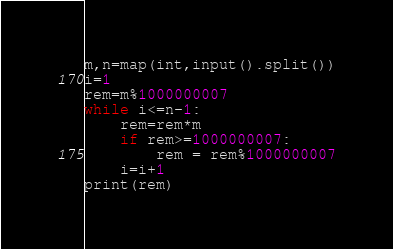<code> <loc_0><loc_0><loc_500><loc_500><_Python_>m,n=map(int,input().split())
i=1
rem=m%1000000007
while i<=n-1:
    rem=rem*m
    if rem>=1000000007:
        rem = rem%1000000007
    i=i+1
print(rem)</code> 